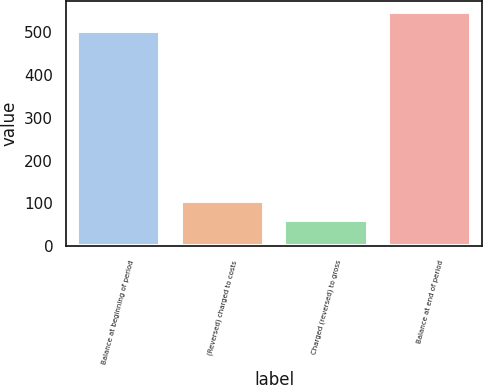Convert chart to OTSL. <chart><loc_0><loc_0><loc_500><loc_500><bar_chart><fcel>Balance at beginning of period<fcel>(Reversed) charged to costs<fcel>Charged (reversed) to gross<fcel>Balance at end of period<nl><fcel>501<fcel>104.94<fcel>60.6<fcel>545.34<nl></chart> 